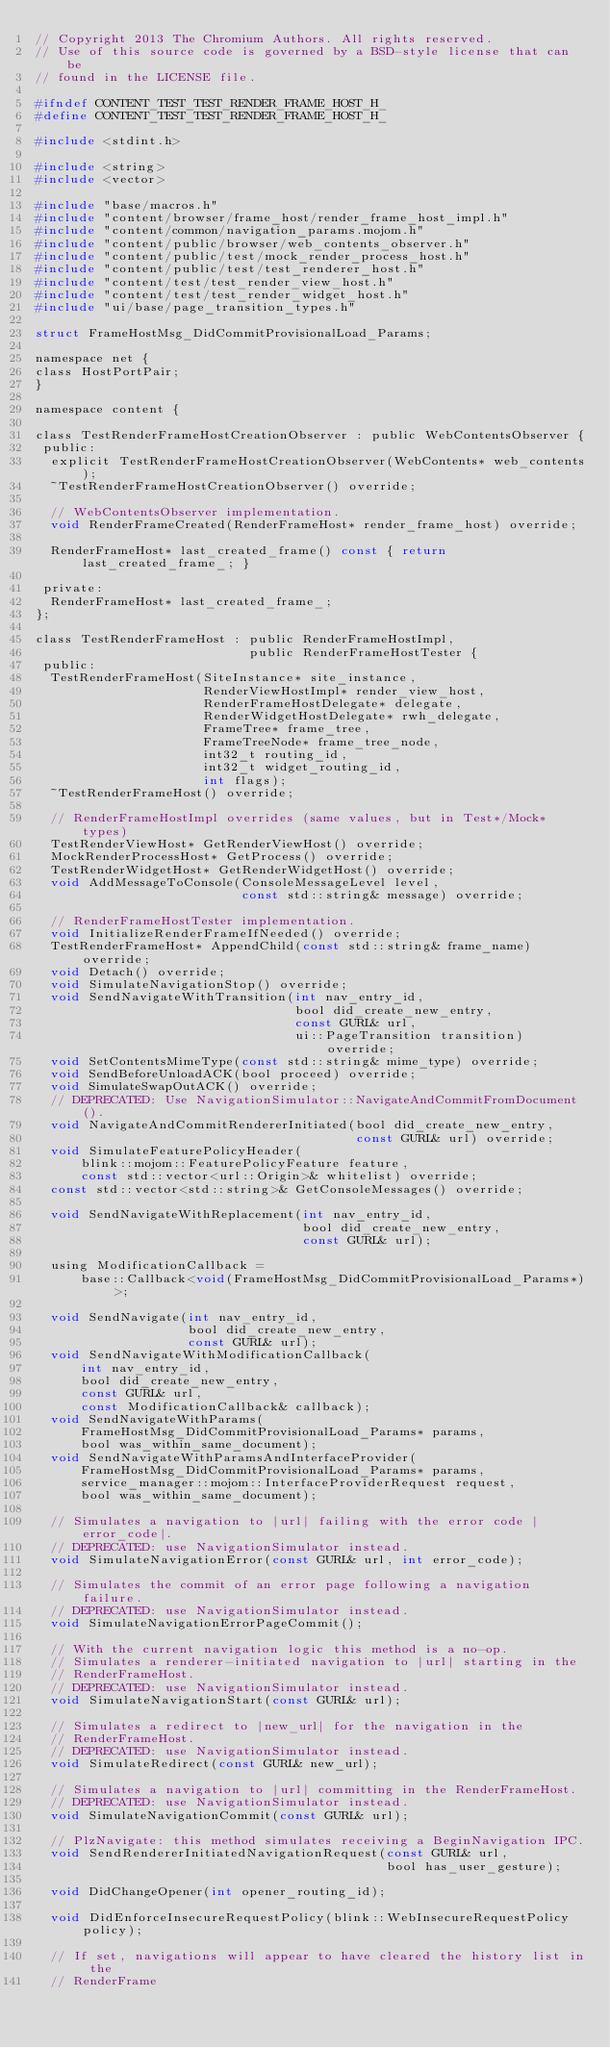Convert code to text. <code><loc_0><loc_0><loc_500><loc_500><_C_>// Copyright 2013 The Chromium Authors. All rights reserved.
// Use of this source code is governed by a BSD-style license that can be
// found in the LICENSE file.

#ifndef CONTENT_TEST_TEST_RENDER_FRAME_HOST_H_
#define CONTENT_TEST_TEST_RENDER_FRAME_HOST_H_

#include <stdint.h>

#include <string>
#include <vector>

#include "base/macros.h"
#include "content/browser/frame_host/render_frame_host_impl.h"
#include "content/common/navigation_params.mojom.h"
#include "content/public/browser/web_contents_observer.h"
#include "content/public/test/mock_render_process_host.h"
#include "content/public/test/test_renderer_host.h"
#include "content/test/test_render_view_host.h"
#include "content/test/test_render_widget_host.h"
#include "ui/base/page_transition_types.h"

struct FrameHostMsg_DidCommitProvisionalLoad_Params;

namespace net {
class HostPortPair;
}

namespace content {

class TestRenderFrameHostCreationObserver : public WebContentsObserver {
 public:
  explicit TestRenderFrameHostCreationObserver(WebContents* web_contents);
  ~TestRenderFrameHostCreationObserver() override;

  // WebContentsObserver implementation.
  void RenderFrameCreated(RenderFrameHost* render_frame_host) override;

  RenderFrameHost* last_created_frame() const { return last_created_frame_; }

 private:
  RenderFrameHost* last_created_frame_;
};

class TestRenderFrameHost : public RenderFrameHostImpl,
                            public RenderFrameHostTester {
 public:
  TestRenderFrameHost(SiteInstance* site_instance,
                      RenderViewHostImpl* render_view_host,
                      RenderFrameHostDelegate* delegate,
                      RenderWidgetHostDelegate* rwh_delegate,
                      FrameTree* frame_tree,
                      FrameTreeNode* frame_tree_node,
                      int32_t routing_id,
                      int32_t widget_routing_id,
                      int flags);
  ~TestRenderFrameHost() override;

  // RenderFrameHostImpl overrides (same values, but in Test*/Mock* types)
  TestRenderViewHost* GetRenderViewHost() override;
  MockRenderProcessHost* GetProcess() override;
  TestRenderWidgetHost* GetRenderWidgetHost() override;
  void AddMessageToConsole(ConsoleMessageLevel level,
                           const std::string& message) override;

  // RenderFrameHostTester implementation.
  void InitializeRenderFrameIfNeeded() override;
  TestRenderFrameHost* AppendChild(const std::string& frame_name) override;
  void Detach() override;
  void SimulateNavigationStop() override;
  void SendNavigateWithTransition(int nav_entry_id,
                                  bool did_create_new_entry,
                                  const GURL& url,
                                  ui::PageTransition transition) override;
  void SetContentsMimeType(const std::string& mime_type) override;
  void SendBeforeUnloadACK(bool proceed) override;
  void SimulateSwapOutACK() override;
  // DEPRECATED: Use NavigationSimulator::NavigateAndCommitFromDocument().
  void NavigateAndCommitRendererInitiated(bool did_create_new_entry,
                                          const GURL& url) override;
  void SimulateFeaturePolicyHeader(
      blink::mojom::FeaturePolicyFeature feature,
      const std::vector<url::Origin>& whitelist) override;
  const std::vector<std::string>& GetConsoleMessages() override;

  void SendNavigateWithReplacement(int nav_entry_id,
                                   bool did_create_new_entry,
                                   const GURL& url);

  using ModificationCallback =
      base::Callback<void(FrameHostMsg_DidCommitProvisionalLoad_Params*)>;

  void SendNavigate(int nav_entry_id,
                    bool did_create_new_entry,
                    const GURL& url);
  void SendNavigateWithModificationCallback(
      int nav_entry_id,
      bool did_create_new_entry,
      const GURL& url,
      const ModificationCallback& callback);
  void SendNavigateWithParams(
      FrameHostMsg_DidCommitProvisionalLoad_Params* params,
      bool was_within_same_document);
  void SendNavigateWithParamsAndInterfaceProvider(
      FrameHostMsg_DidCommitProvisionalLoad_Params* params,
      service_manager::mojom::InterfaceProviderRequest request,
      bool was_within_same_document);

  // Simulates a navigation to |url| failing with the error code |error_code|.
  // DEPRECATED: use NavigationSimulator instead.
  void SimulateNavigationError(const GURL& url, int error_code);

  // Simulates the commit of an error page following a navigation failure.
  // DEPRECATED: use NavigationSimulator instead.
  void SimulateNavigationErrorPageCommit();

  // With the current navigation logic this method is a no-op.
  // Simulates a renderer-initiated navigation to |url| starting in the
  // RenderFrameHost.
  // DEPRECATED: use NavigationSimulator instead.
  void SimulateNavigationStart(const GURL& url);

  // Simulates a redirect to |new_url| for the navigation in the
  // RenderFrameHost.
  // DEPRECATED: use NavigationSimulator instead.
  void SimulateRedirect(const GURL& new_url);

  // Simulates a navigation to |url| committing in the RenderFrameHost.
  // DEPRECATED: use NavigationSimulator instead.
  void SimulateNavigationCommit(const GURL& url);

  // PlzNavigate: this method simulates receiving a BeginNavigation IPC.
  void SendRendererInitiatedNavigationRequest(const GURL& url,
                                              bool has_user_gesture);

  void DidChangeOpener(int opener_routing_id);

  void DidEnforceInsecureRequestPolicy(blink::WebInsecureRequestPolicy policy);

  // If set, navigations will appear to have cleared the history list in the
  // RenderFrame</code> 